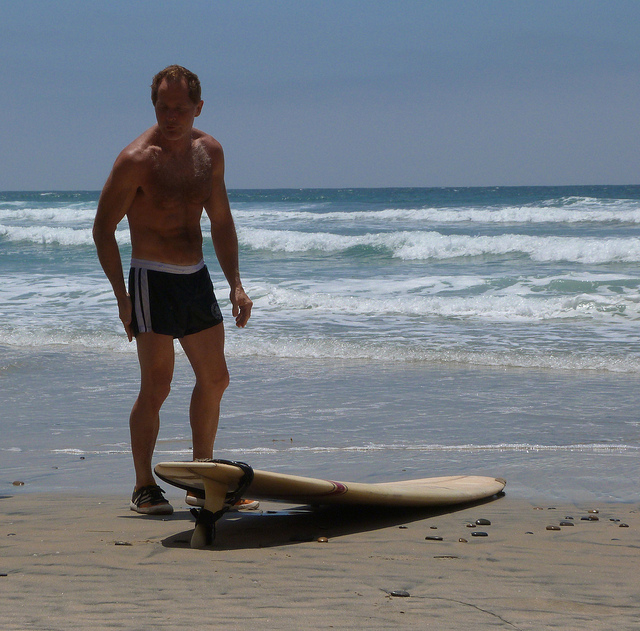What personal significance might the surfboard have for the man? The surfboard might hold significant personal value for the man, perhaps gifted to him by a family member or friend. It could be a reminder of cherished memories and experiences, both past and future, symbolizing his connection to the sea and his love for surfing. 